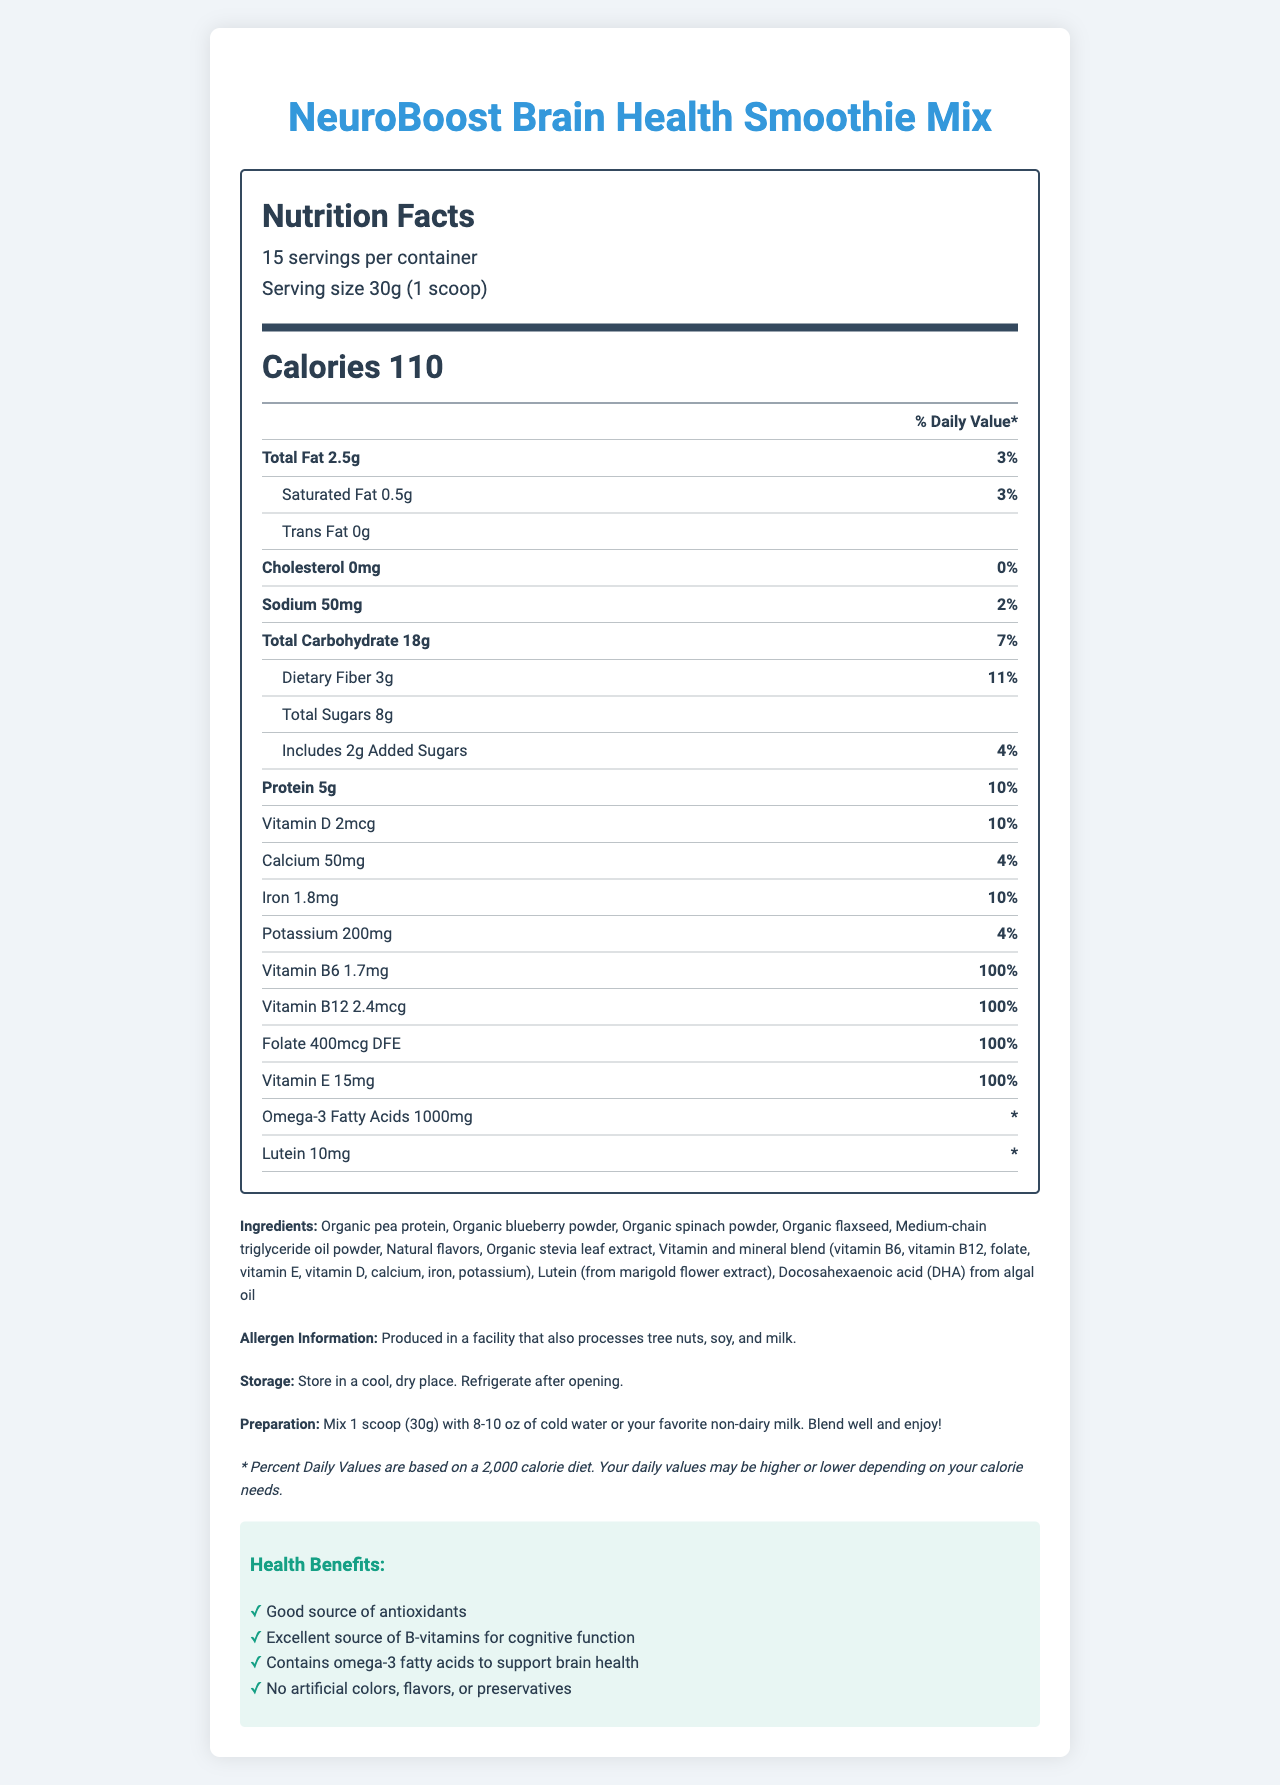what is the serving size? The document states that the serving size is 30g, which equals 1 scoop.
Answer: 30g (1 scoop) how many calories are in one serving? The Nutrition Facts section indicates that there are 110 calories per serving.
Answer: 110 what percentage of the Daily Value is the Vitamin E content? The document shows Vitamin E content as 15mg, which is 100% of the Daily Value.
Answer: 100% which ingredient is the source of DHA? In the ingredients list, DHA is specified to come from algal oil.
Answer: Docosahexaenoic acid (DHA) from algal oil how much protein is there in one serving? The Nutrition Facts label specifies that there are 5g of protein per serving.
Answer: 5g how many servings are there per container? The document clearly states that there are 15 servings per container.
Answer: 15 what is the total fat content per serving? A. 2g B. 2.5g C. 3g The Nutrition Facts label specifies that the total fat content per serving is 2.5g.
Answer: B which has the highest daily value percentage? A. Vitamin D B. Vitamin B6 C. Folate Vitamin B6, Vitamin B12, Folate, and Vitamin E each have a daily value of 100%, but compared to Vitamin D which has only 10%, the highest would be Vitamin B6.
Answer: B is there any added sugar in the product? The Nutrition Facts label indicates that there are 2g of added sugars.
Answer: Yes does the product contain any artificial colors or flavors? The health claims section mentions that the product contains no artificial colors, flavors, or preservatives.
Answer: No what is the main purpose of this document? The document includes sections on serving size, calories, detailed nutrient information, ingredients list, allergen info, storage/preparation instructions, and health benefits, making it comprehensive for the product.
Answer: The main purpose of this document is to provide a detailed overview of the nutrition facts, ingredients, and health benefits of the NeuroBoost Brain Health Smoothie Mix. are tree nuts processed in the same facility as this product? True or False The allergen information mentions that the product is produced in a facility that also processes tree nuts.
Answer: True what is not listed on the Nutrition Facts label? The document does not provide any information about the manufacturing process of the product.
Answer: Any details about the manufacturing process 